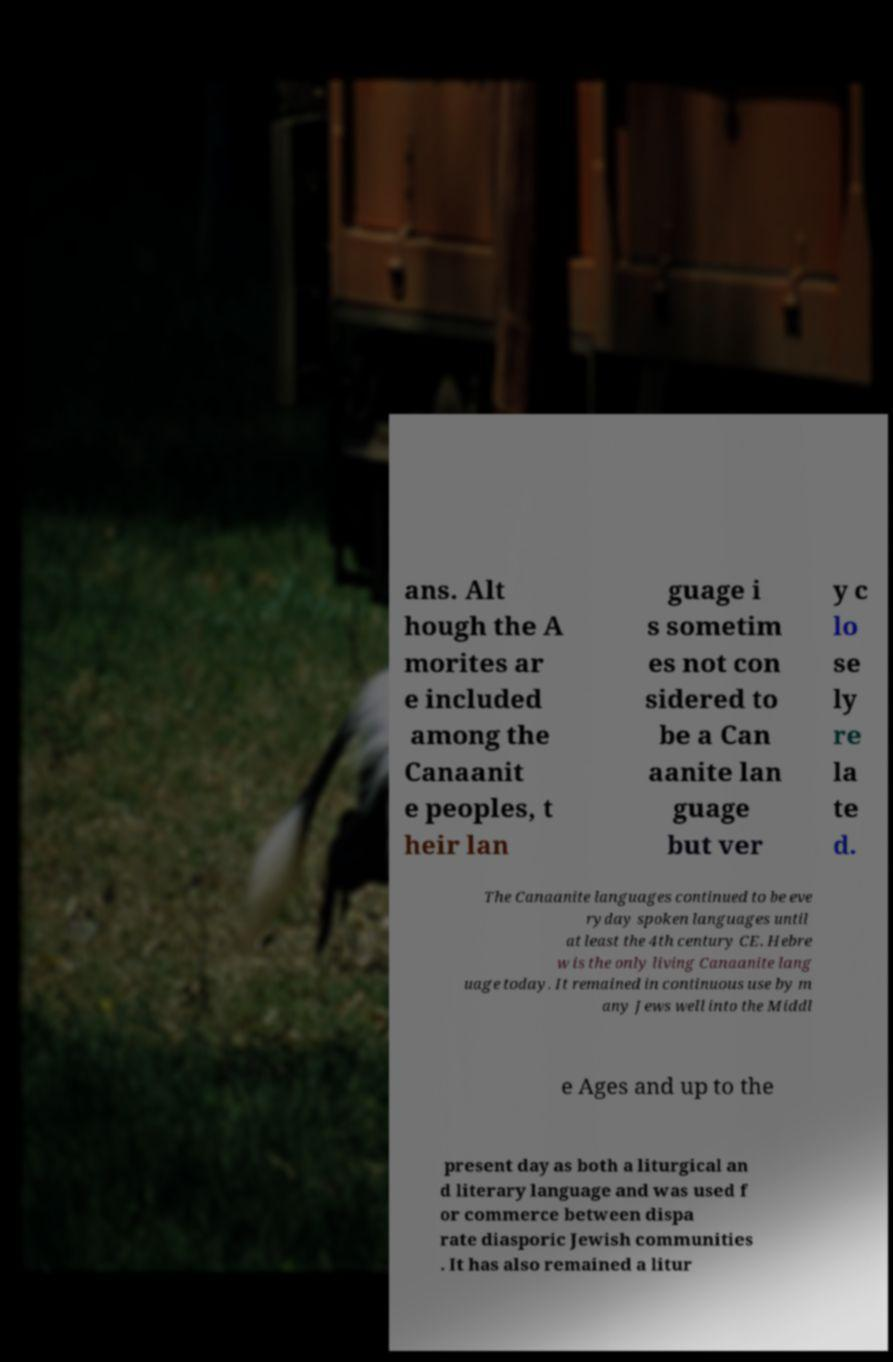What messages or text are displayed in this image? I need them in a readable, typed format. ans. Alt hough the A morites ar e included among the Canaanit e peoples, t heir lan guage i s sometim es not con sidered to be a Can aanite lan guage but ver y c lo se ly re la te d. The Canaanite languages continued to be eve ryday spoken languages until at least the 4th century CE. Hebre w is the only living Canaanite lang uage today. It remained in continuous use by m any Jews well into the Middl e Ages and up to the present day as both a liturgical an d literary language and was used f or commerce between dispa rate diasporic Jewish communities . It has also remained a litur 